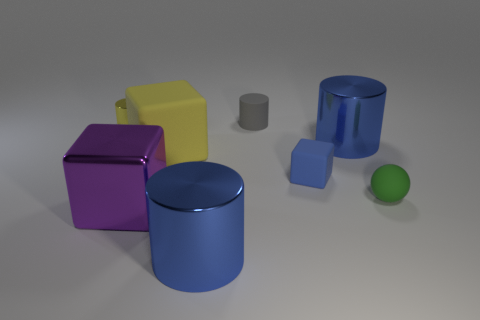There is a blue object that is the same size as the green ball; what material is it?
Provide a succinct answer. Rubber. What material is the thing that is the same color as the small metallic cylinder?
Make the answer very short. Rubber. What number of metallic cylinders are behind the metallic cylinder that is to the right of the small gray matte cylinder that is to the left of the green object?
Your response must be concise. 1. What number of cyan objects are either big rubber objects or blocks?
Your answer should be compact. 0. There is a ball that is made of the same material as the small gray object; what is its color?
Offer a very short reply. Green. What number of big things are either gray matte cylinders or metal cylinders?
Your response must be concise. 2. Are there fewer gray rubber cylinders than small yellow blocks?
Offer a terse response. No. What is the color of the other large object that is the same shape as the purple metallic thing?
Provide a short and direct response. Yellow. Are there any other things that have the same shape as the small green rubber object?
Ensure brevity in your answer.  No. Are there more yellow rubber things than blue metallic objects?
Provide a short and direct response. No. 